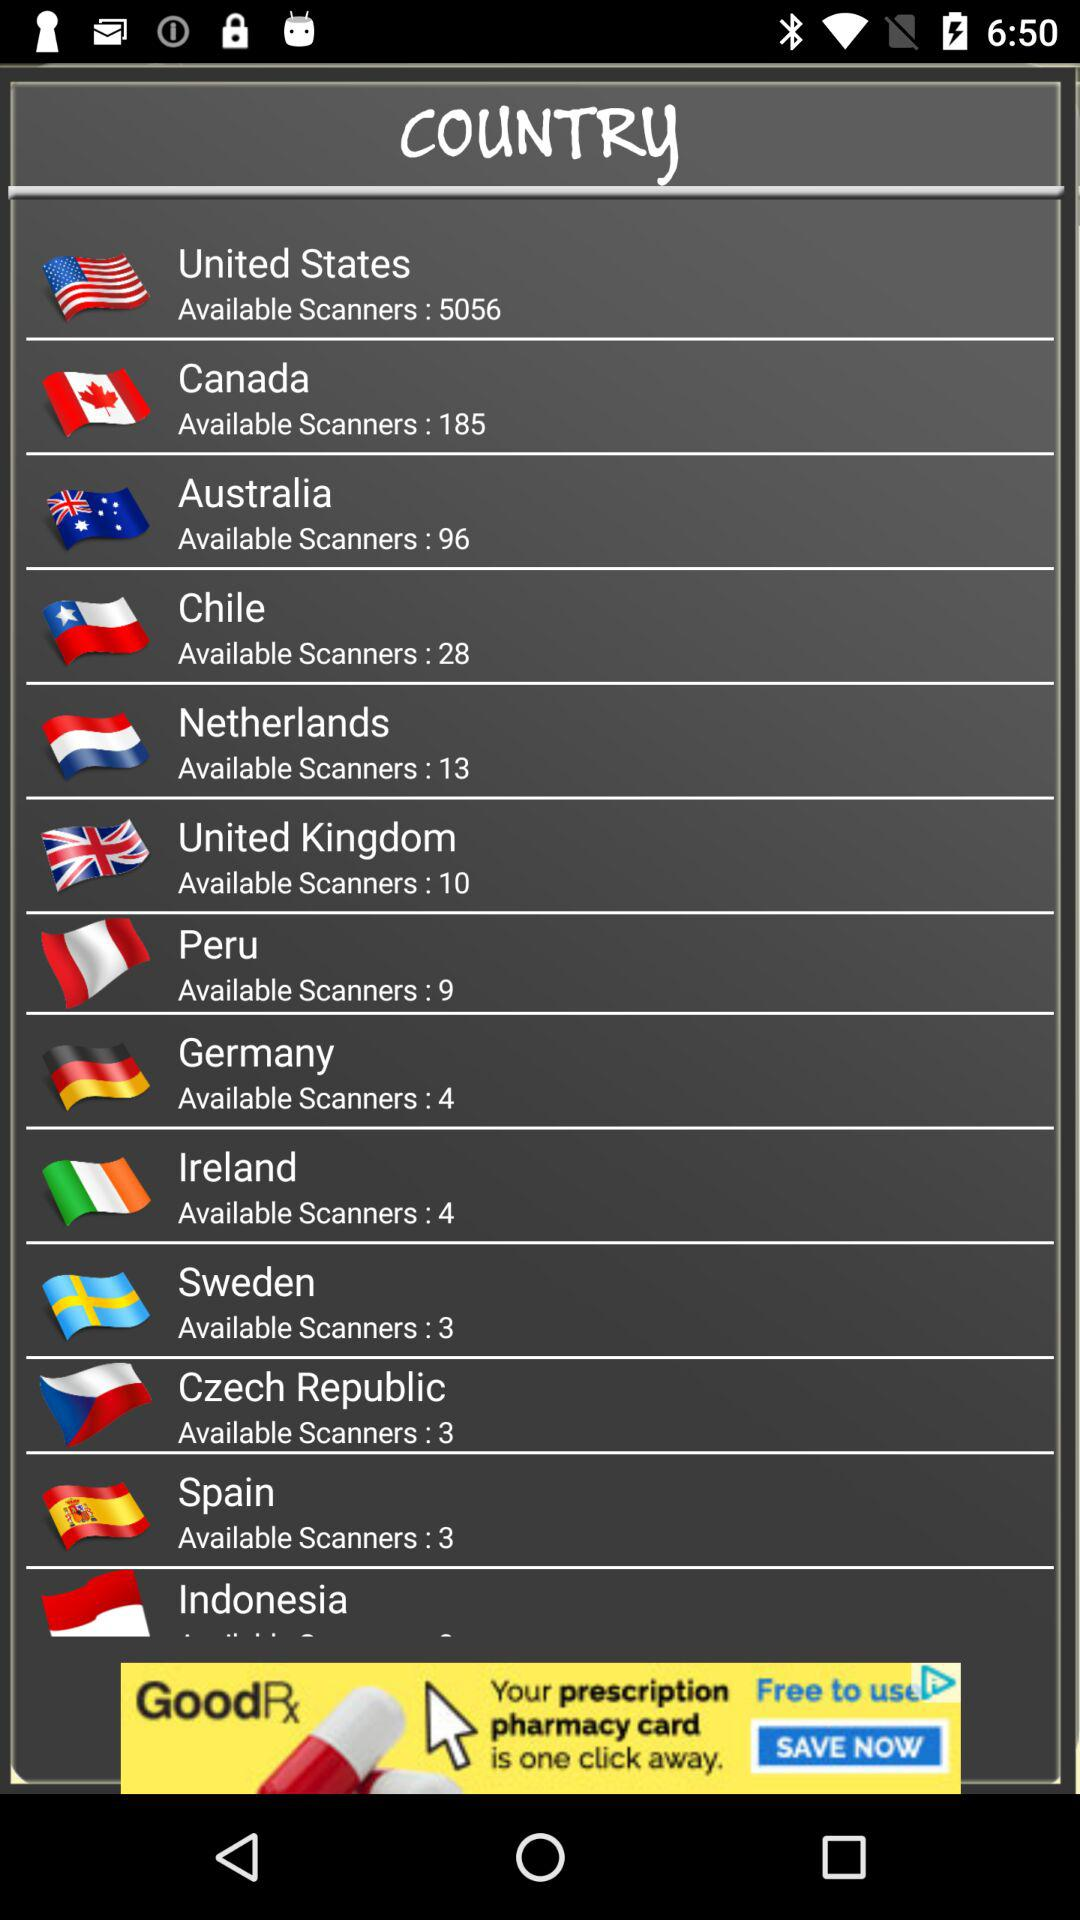What is the number of available scanners in Chile? There are 28 available scanners. 